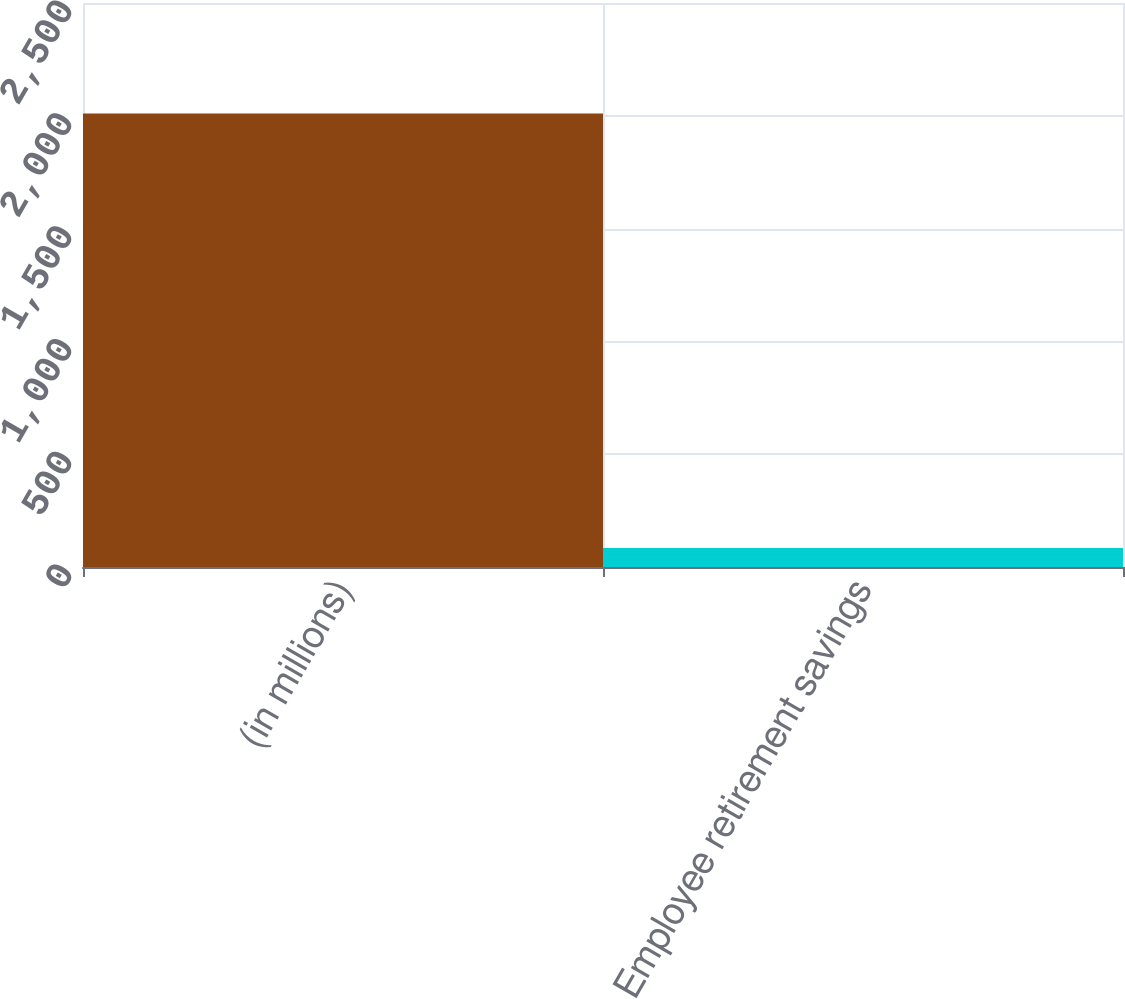Convert chart. <chart><loc_0><loc_0><loc_500><loc_500><bar_chart><fcel>(in millions)<fcel>Employee retirement savings<nl><fcel>2010<fcel>84.3<nl></chart> 